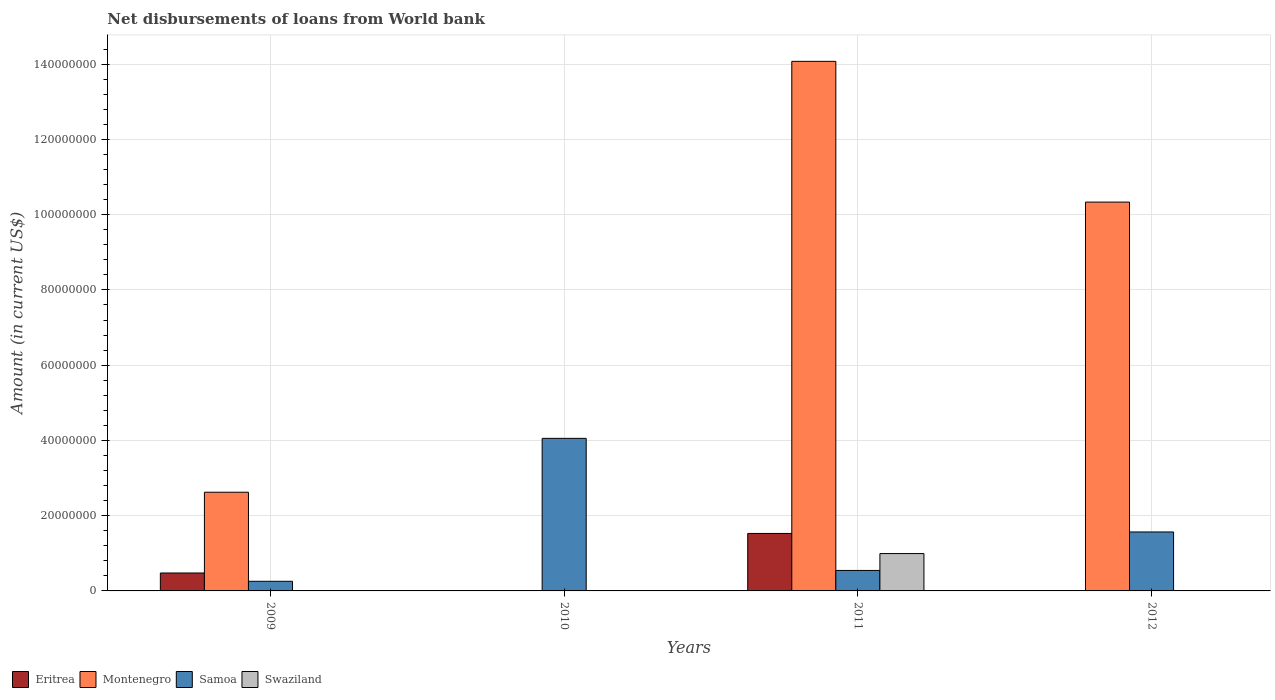How many different coloured bars are there?
Offer a terse response. 4. How many groups of bars are there?
Provide a short and direct response. 4. Are the number of bars on each tick of the X-axis equal?
Your answer should be compact. No. How many bars are there on the 1st tick from the left?
Your response must be concise. 3. How many bars are there on the 3rd tick from the right?
Keep it short and to the point. 2. In how many cases, is the number of bars for a given year not equal to the number of legend labels?
Provide a short and direct response. 3. What is the amount of loan disbursed from World Bank in Samoa in 2012?
Provide a succinct answer. 1.57e+07. Across all years, what is the maximum amount of loan disbursed from World Bank in Samoa?
Ensure brevity in your answer.  4.05e+07. In which year was the amount of loan disbursed from World Bank in Eritrea maximum?
Give a very brief answer. 2011. What is the total amount of loan disbursed from World Bank in Swaziland in the graph?
Provide a succinct answer. 9.92e+06. What is the difference between the amount of loan disbursed from World Bank in Montenegro in 2009 and that in 2012?
Provide a short and direct response. -7.71e+07. What is the difference between the amount of loan disbursed from World Bank in Eritrea in 2010 and the amount of loan disbursed from World Bank in Montenegro in 2012?
Keep it short and to the point. -1.03e+08. What is the average amount of loan disbursed from World Bank in Montenegro per year?
Offer a very short reply. 6.76e+07. In the year 2010, what is the difference between the amount of loan disbursed from World Bank in Eritrea and amount of loan disbursed from World Bank in Samoa?
Your answer should be compact. -4.04e+07. What is the ratio of the amount of loan disbursed from World Bank in Eritrea in 2010 to that in 2011?
Keep it short and to the point. 0.01. Is the difference between the amount of loan disbursed from World Bank in Eritrea in 2010 and 2011 greater than the difference between the amount of loan disbursed from World Bank in Samoa in 2010 and 2011?
Provide a succinct answer. No. What is the difference between the highest and the second highest amount of loan disbursed from World Bank in Montenegro?
Make the answer very short. 3.74e+07. What is the difference between the highest and the lowest amount of loan disbursed from World Bank in Samoa?
Give a very brief answer. 3.80e+07. Is the sum of the amount of loan disbursed from World Bank in Samoa in 2009 and 2010 greater than the maximum amount of loan disbursed from World Bank in Swaziland across all years?
Your response must be concise. Yes. Is it the case that in every year, the sum of the amount of loan disbursed from World Bank in Eritrea and amount of loan disbursed from World Bank in Swaziland is greater than the amount of loan disbursed from World Bank in Montenegro?
Keep it short and to the point. No. How many years are there in the graph?
Provide a short and direct response. 4. Are the values on the major ticks of Y-axis written in scientific E-notation?
Offer a terse response. No. Where does the legend appear in the graph?
Your answer should be very brief. Bottom left. What is the title of the graph?
Provide a short and direct response. Net disbursements of loans from World bank. What is the label or title of the X-axis?
Keep it short and to the point. Years. What is the label or title of the Y-axis?
Your answer should be very brief. Amount (in current US$). What is the Amount (in current US$) in Eritrea in 2009?
Your response must be concise. 4.76e+06. What is the Amount (in current US$) of Montenegro in 2009?
Offer a very short reply. 2.62e+07. What is the Amount (in current US$) of Samoa in 2009?
Your answer should be very brief. 2.56e+06. What is the Amount (in current US$) in Eritrea in 2010?
Your response must be concise. 1.08e+05. What is the Amount (in current US$) of Samoa in 2010?
Your response must be concise. 4.05e+07. What is the Amount (in current US$) of Swaziland in 2010?
Provide a short and direct response. 0. What is the Amount (in current US$) in Eritrea in 2011?
Ensure brevity in your answer.  1.53e+07. What is the Amount (in current US$) of Montenegro in 2011?
Make the answer very short. 1.41e+08. What is the Amount (in current US$) of Samoa in 2011?
Your answer should be compact. 5.44e+06. What is the Amount (in current US$) in Swaziland in 2011?
Ensure brevity in your answer.  9.92e+06. What is the Amount (in current US$) of Montenegro in 2012?
Your answer should be very brief. 1.03e+08. What is the Amount (in current US$) of Samoa in 2012?
Give a very brief answer. 1.57e+07. What is the Amount (in current US$) in Swaziland in 2012?
Your answer should be compact. 0. Across all years, what is the maximum Amount (in current US$) in Eritrea?
Your answer should be compact. 1.53e+07. Across all years, what is the maximum Amount (in current US$) of Montenegro?
Your answer should be very brief. 1.41e+08. Across all years, what is the maximum Amount (in current US$) in Samoa?
Ensure brevity in your answer.  4.05e+07. Across all years, what is the maximum Amount (in current US$) of Swaziland?
Ensure brevity in your answer.  9.92e+06. Across all years, what is the minimum Amount (in current US$) in Samoa?
Your response must be concise. 2.56e+06. Across all years, what is the minimum Amount (in current US$) of Swaziland?
Offer a very short reply. 0. What is the total Amount (in current US$) of Eritrea in the graph?
Your response must be concise. 2.01e+07. What is the total Amount (in current US$) in Montenegro in the graph?
Your response must be concise. 2.70e+08. What is the total Amount (in current US$) of Samoa in the graph?
Provide a succinct answer. 6.42e+07. What is the total Amount (in current US$) of Swaziland in the graph?
Your answer should be compact. 9.92e+06. What is the difference between the Amount (in current US$) of Eritrea in 2009 and that in 2010?
Give a very brief answer. 4.66e+06. What is the difference between the Amount (in current US$) in Samoa in 2009 and that in 2010?
Make the answer very short. -3.80e+07. What is the difference between the Amount (in current US$) of Eritrea in 2009 and that in 2011?
Offer a terse response. -1.05e+07. What is the difference between the Amount (in current US$) in Montenegro in 2009 and that in 2011?
Your response must be concise. -1.15e+08. What is the difference between the Amount (in current US$) in Samoa in 2009 and that in 2011?
Keep it short and to the point. -2.88e+06. What is the difference between the Amount (in current US$) of Montenegro in 2009 and that in 2012?
Your response must be concise. -7.71e+07. What is the difference between the Amount (in current US$) of Samoa in 2009 and that in 2012?
Your answer should be compact. -1.31e+07. What is the difference between the Amount (in current US$) in Eritrea in 2010 and that in 2011?
Offer a very short reply. -1.52e+07. What is the difference between the Amount (in current US$) of Samoa in 2010 and that in 2011?
Provide a short and direct response. 3.51e+07. What is the difference between the Amount (in current US$) in Samoa in 2010 and that in 2012?
Your response must be concise. 2.49e+07. What is the difference between the Amount (in current US$) of Montenegro in 2011 and that in 2012?
Ensure brevity in your answer.  3.74e+07. What is the difference between the Amount (in current US$) of Samoa in 2011 and that in 2012?
Give a very brief answer. -1.02e+07. What is the difference between the Amount (in current US$) in Eritrea in 2009 and the Amount (in current US$) in Samoa in 2010?
Provide a short and direct response. -3.58e+07. What is the difference between the Amount (in current US$) of Montenegro in 2009 and the Amount (in current US$) of Samoa in 2010?
Offer a very short reply. -1.43e+07. What is the difference between the Amount (in current US$) of Eritrea in 2009 and the Amount (in current US$) of Montenegro in 2011?
Offer a very short reply. -1.36e+08. What is the difference between the Amount (in current US$) of Eritrea in 2009 and the Amount (in current US$) of Samoa in 2011?
Your response must be concise. -6.78e+05. What is the difference between the Amount (in current US$) of Eritrea in 2009 and the Amount (in current US$) of Swaziland in 2011?
Your response must be concise. -5.16e+06. What is the difference between the Amount (in current US$) of Montenegro in 2009 and the Amount (in current US$) of Samoa in 2011?
Ensure brevity in your answer.  2.08e+07. What is the difference between the Amount (in current US$) in Montenegro in 2009 and the Amount (in current US$) in Swaziland in 2011?
Give a very brief answer. 1.63e+07. What is the difference between the Amount (in current US$) of Samoa in 2009 and the Amount (in current US$) of Swaziland in 2011?
Ensure brevity in your answer.  -7.36e+06. What is the difference between the Amount (in current US$) in Eritrea in 2009 and the Amount (in current US$) in Montenegro in 2012?
Your response must be concise. -9.86e+07. What is the difference between the Amount (in current US$) in Eritrea in 2009 and the Amount (in current US$) in Samoa in 2012?
Your answer should be compact. -1.09e+07. What is the difference between the Amount (in current US$) in Montenegro in 2009 and the Amount (in current US$) in Samoa in 2012?
Keep it short and to the point. 1.06e+07. What is the difference between the Amount (in current US$) of Eritrea in 2010 and the Amount (in current US$) of Montenegro in 2011?
Your response must be concise. -1.41e+08. What is the difference between the Amount (in current US$) in Eritrea in 2010 and the Amount (in current US$) in Samoa in 2011?
Offer a very short reply. -5.33e+06. What is the difference between the Amount (in current US$) in Eritrea in 2010 and the Amount (in current US$) in Swaziland in 2011?
Keep it short and to the point. -9.82e+06. What is the difference between the Amount (in current US$) of Samoa in 2010 and the Amount (in current US$) of Swaziland in 2011?
Give a very brief answer. 3.06e+07. What is the difference between the Amount (in current US$) in Eritrea in 2010 and the Amount (in current US$) in Montenegro in 2012?
Offer a very short reply. -1.03e+08. What is the difference between the Amount (in current US$) of Eritrea in 2010 and the Amount (in current US$) of Samoa in 2012?
Your answer should be very brief. -1.56e+07. What is the difference between the Amount (in current US$) in Eritrea in 2011 and the Amount (in current US$) in Montenegro in 2012?
Give a very brief answer. -8.81e+07. What is the difference between the Amount (in current US$) of Eritrea in 2011 and the Amount (in current US$) of Samoa in 2012?
Your answer should be very brief. -3.93e+05. What is the difference between the Amount (in current US$) in Montenegro in 2011 and the Amount (in current US$) in Samoa in 2012?
Provide a succinct answer. 1.25e+08. What is the average Amount (in current US$) of Eritrea per year?
Make the answer very short. 5.04e+06. What is the average Amount (in current US$) in Montenegro per year?
Provide a short and direct response. 6.76e+07. What is the average Amount (in current US$) in Samoa per year?
Provide a short and direct response. 1.61e+07. What is the average Amount (in current US$) of Swaziland per year?
Offer a terse response. 2.48e+06. In the year 2009, what is the difference between the Amount (in current US$) of Eritrea and Amount (in current US$) of Montenegro?
Offer a terse response. -2.15e+07. In the year 2009, what is the difference between the Amount (in current US$) in Eritrea and Amount (in current US$) in Samoa?
Your response must be concise. 2.20e+06. In the year 2009, what is the difference between the Amount (in current US$) in Montenegro and Amount (in current US$) in Samoa?
Your response must be concise. 2.37e+07. In the year 2010, what is the difference between the Amount (in current US$) of Eritrea and Amount (in current US$) of Samoa?
Ensure brevity in your answer.  -4.04e+07. In the year 2011, what is the difference between the Amount (in current US$) in Eritrea and Amount (in current US$) in Montenegro?
Offer a very short reply. -1.25e+08. In the year 2011, what is the difference between the Amount (in current US$) of Eritrea and Amount (in current US$) of Samoa?
Make the answer very short. 9.84e+06. In the year 2011, what is the difference between the Amount (in current US$) of Eritrea and Amount (in current US$) of Swaziland?
Provide a short and direct response. 5.35e+06. In the year 2011, what is the difference between the Amount (in current US$) in Montenegro and Amount (in current US$) in Samoa?
Offer a very short reply. 1.35e+08. In the year 2011, what is the difference between the Amount (in current US$) in Montenegro and Amount (in current US$) in Swaziland?
Provide a short and direct response. 1.31e+08. In the year 2011, what is the difference between the Amount (in current US$) of Samoa and Amount (in current US$) of Swaziland?
Offer a very short reply. -4.48e+06. In the year 2012, what is the difference between the Amount (in current US$) in Montenegro and Amount (in current US$) in Samoa?
Offer a terse response. 8.77e+07. What is the ratio of the Amount (in current US$) in Eritrea in 2009 to that in 2010?
Your answer should be compact. 44.1. What is the ratio of the Amount (in current US$) of Samoa in 2009 to that in 2010?
Give a very brief answer. 0.06. What is the ratio of the Amount (in current US$) in Eritrea in 2009 to that in 2011?
Make the answer very short. 0.31. What is the ratio of the Amount (in current US$) in Montenegro in 2009 to that in 2011?
Offer a very short reply. 0.19. What is the ratio of the Amount (in current US$) of Samoa in 2009 to that in 2011?
Provide a short and direct response. 0.47. What is the ratio of the Amount (in current US$) in Montenegro in 2009 to that in 2012?
Provide a short and direct response. 0.25. What is the ratio of the Amount (in current US$) of Samoa in 2009 to that in 2012?
Offer a very short reply. 0.16. What is the ratio of the Amount (in current US$) in Eritrea in 2010 to that in 2011?
Offer a very short reply. 0.01. What is the ratio of the Amount (in current US$) in Samoa in 2010 to that in 2011?
Provide a short and direct response. 7.45. What is the ratio of the Amount (in current US$) of Samoa in 2010 to that in 2012?
Your response must be concise. 2.59. What is the ratio of the Amount (in current US$) in Montenegro in 2011 to that in 2012?
Your response must be concise. 1.36. What is the ratio of the Amount (in current US$) of Samoa in 2011 to that in 2012?
Give a very brief answer. 0.35. What is the difference between the highest and the second highest Amount (in current US$) of Eritrea?
Provide a succinct answer. 1.05e+07. What is the difference between the highest and the second highest Amount (in current US$) of Montenegro?
Your answer should be very brief. 3.74e+07. What is the difference between the highest and the second highest Amount (in current US$) in Samoa?
Keep it short and to the point. 2.49e+07. What is the difference between the highest and the lowest Amount (in current US$) of Eritrea?
Keep it short and to the point. 1.53e+07. What is the difference between the highest and the lowest Amount (in current US$) in Montenegro?
Your answer should be compact. 1.41e+08. What is the difference between the highest and the lowest Amount (in current US$) in Samoa?
Keep it short and to the point. 3.80e+07. What is the difference between the highest and the lowest Amount (in current US$) of Swaziland?
Your answer should be compact. 9.92e+06. 